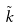<formula> <loc_0><loc_0><loc_500><loc_500>\tilde { k }</formula> 